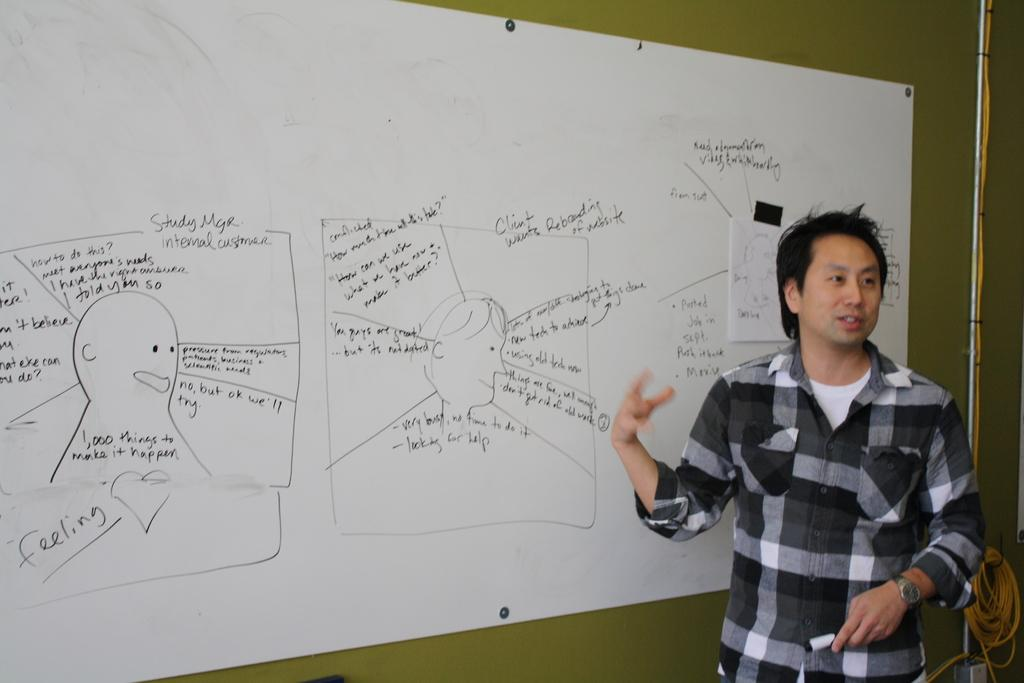<image>
Present a compact description of the photo's key features. A young man stands in front of a white board that has words like feeling on it. 